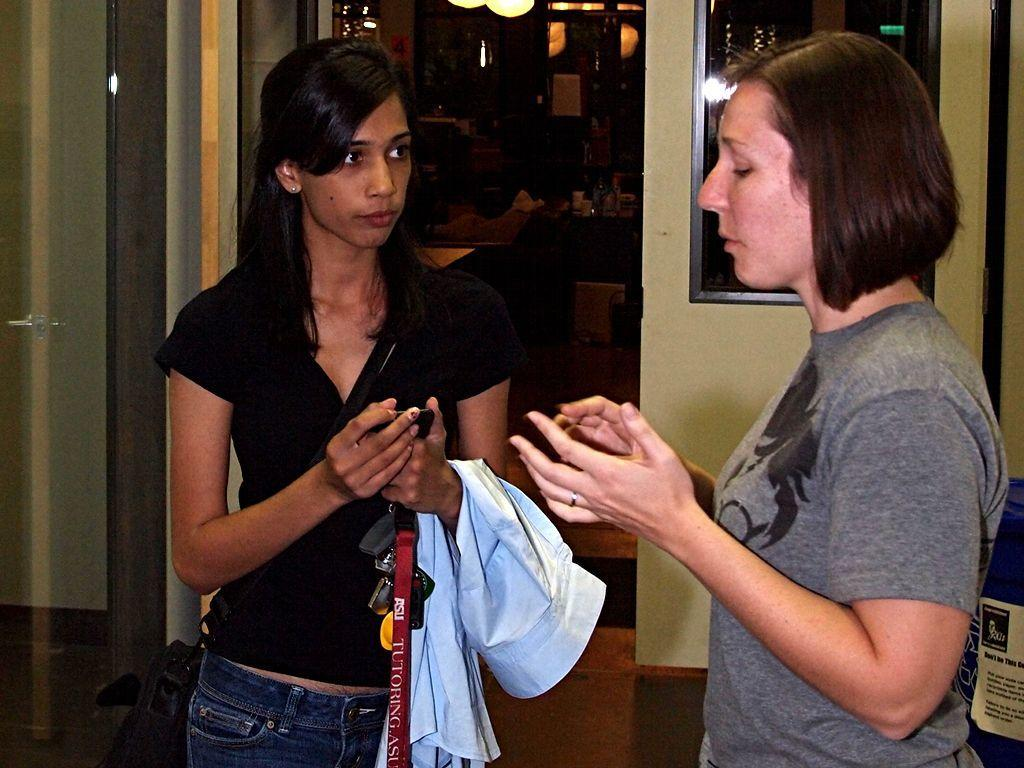How many people are in the image? There are two women standing in the image. What are the women wearing? The women are wearing clothes. What might the women be doing in the image? The women appear to be talking to each other. Can you describe the frame in the image? The frame is attached to a wall and a floor. What else can be seen in the image? There are lights visible in the image. What type of degree is hanging on the wall in the image? There is no degree visible in the image; only a frame is mentioned. Can you see a basket in the image? There is no basket present in the image. 